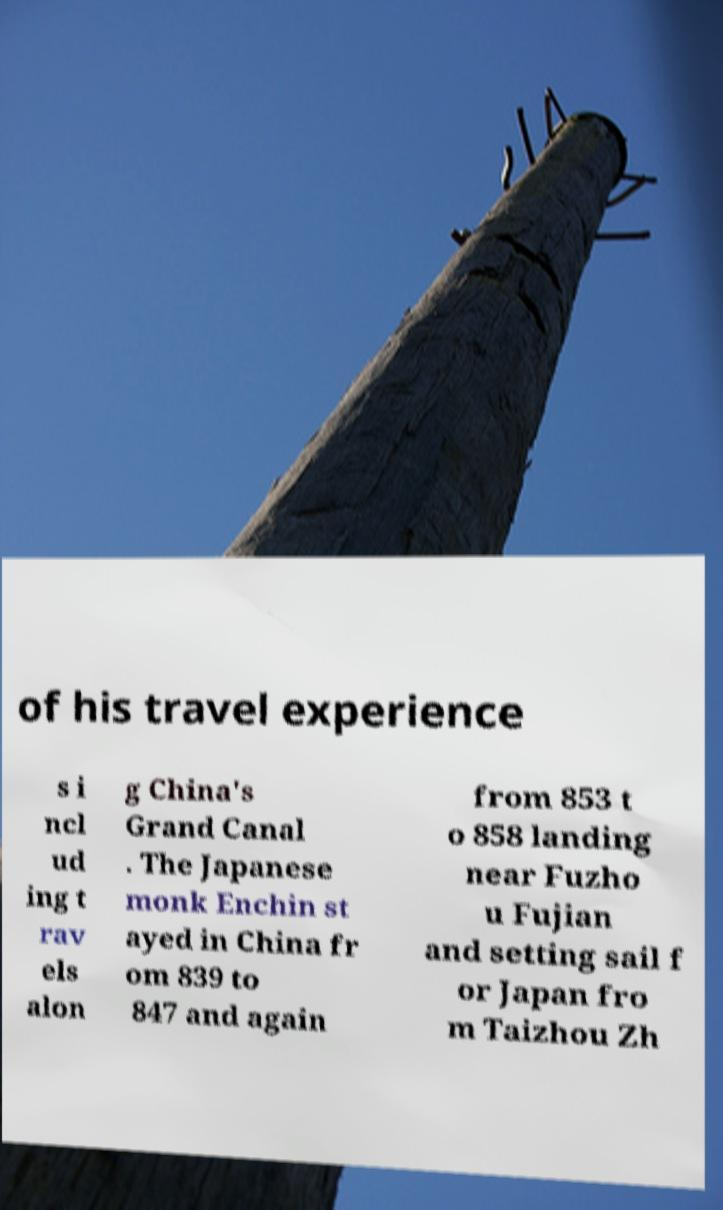Could you assist in decoding the text presented in this image and type it out clearly? of his travel experience s i ncl ud ing t rav els alon g China's Grand Canal . The Japanese monk Enchin st ayed in China fr om 839 to 847 and again from 853 t o 858 landing near Fuzho u Fujian and setting sail f or Japan fro m Taizhou Zh 